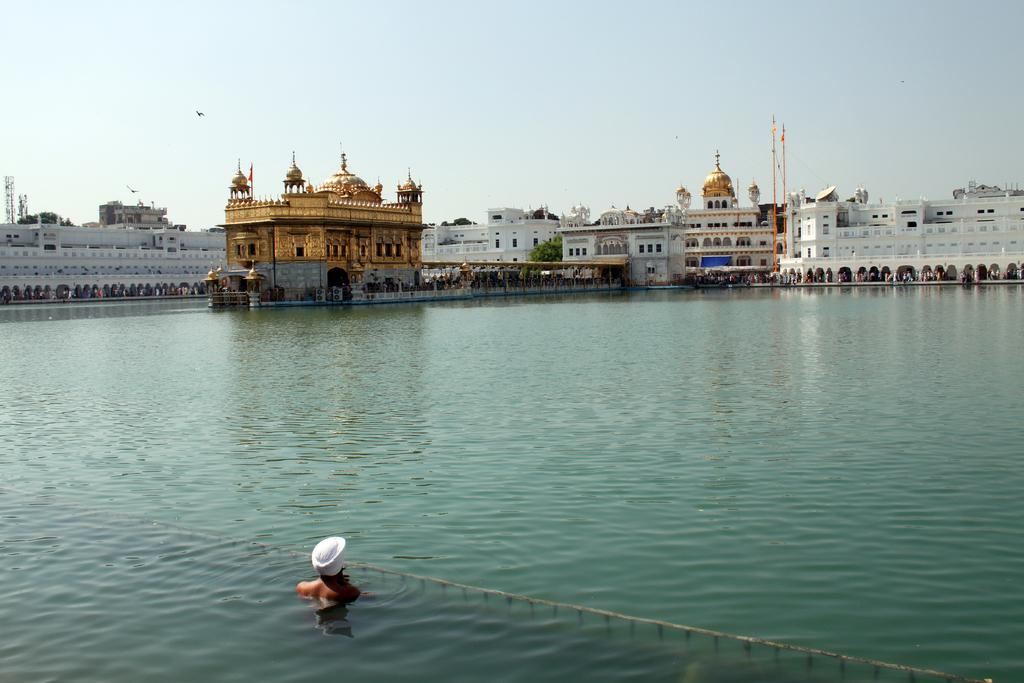What is the person in the image doing? The person is in the water. What can be seen in the background of the image? There are buildings, poles, trees, and other persons in the background. What is visible in the sky in the image? The sky is visible in the background of the image. What type of work is the person doing in the water? The image does not show the person working or performing any specific task in the water. 